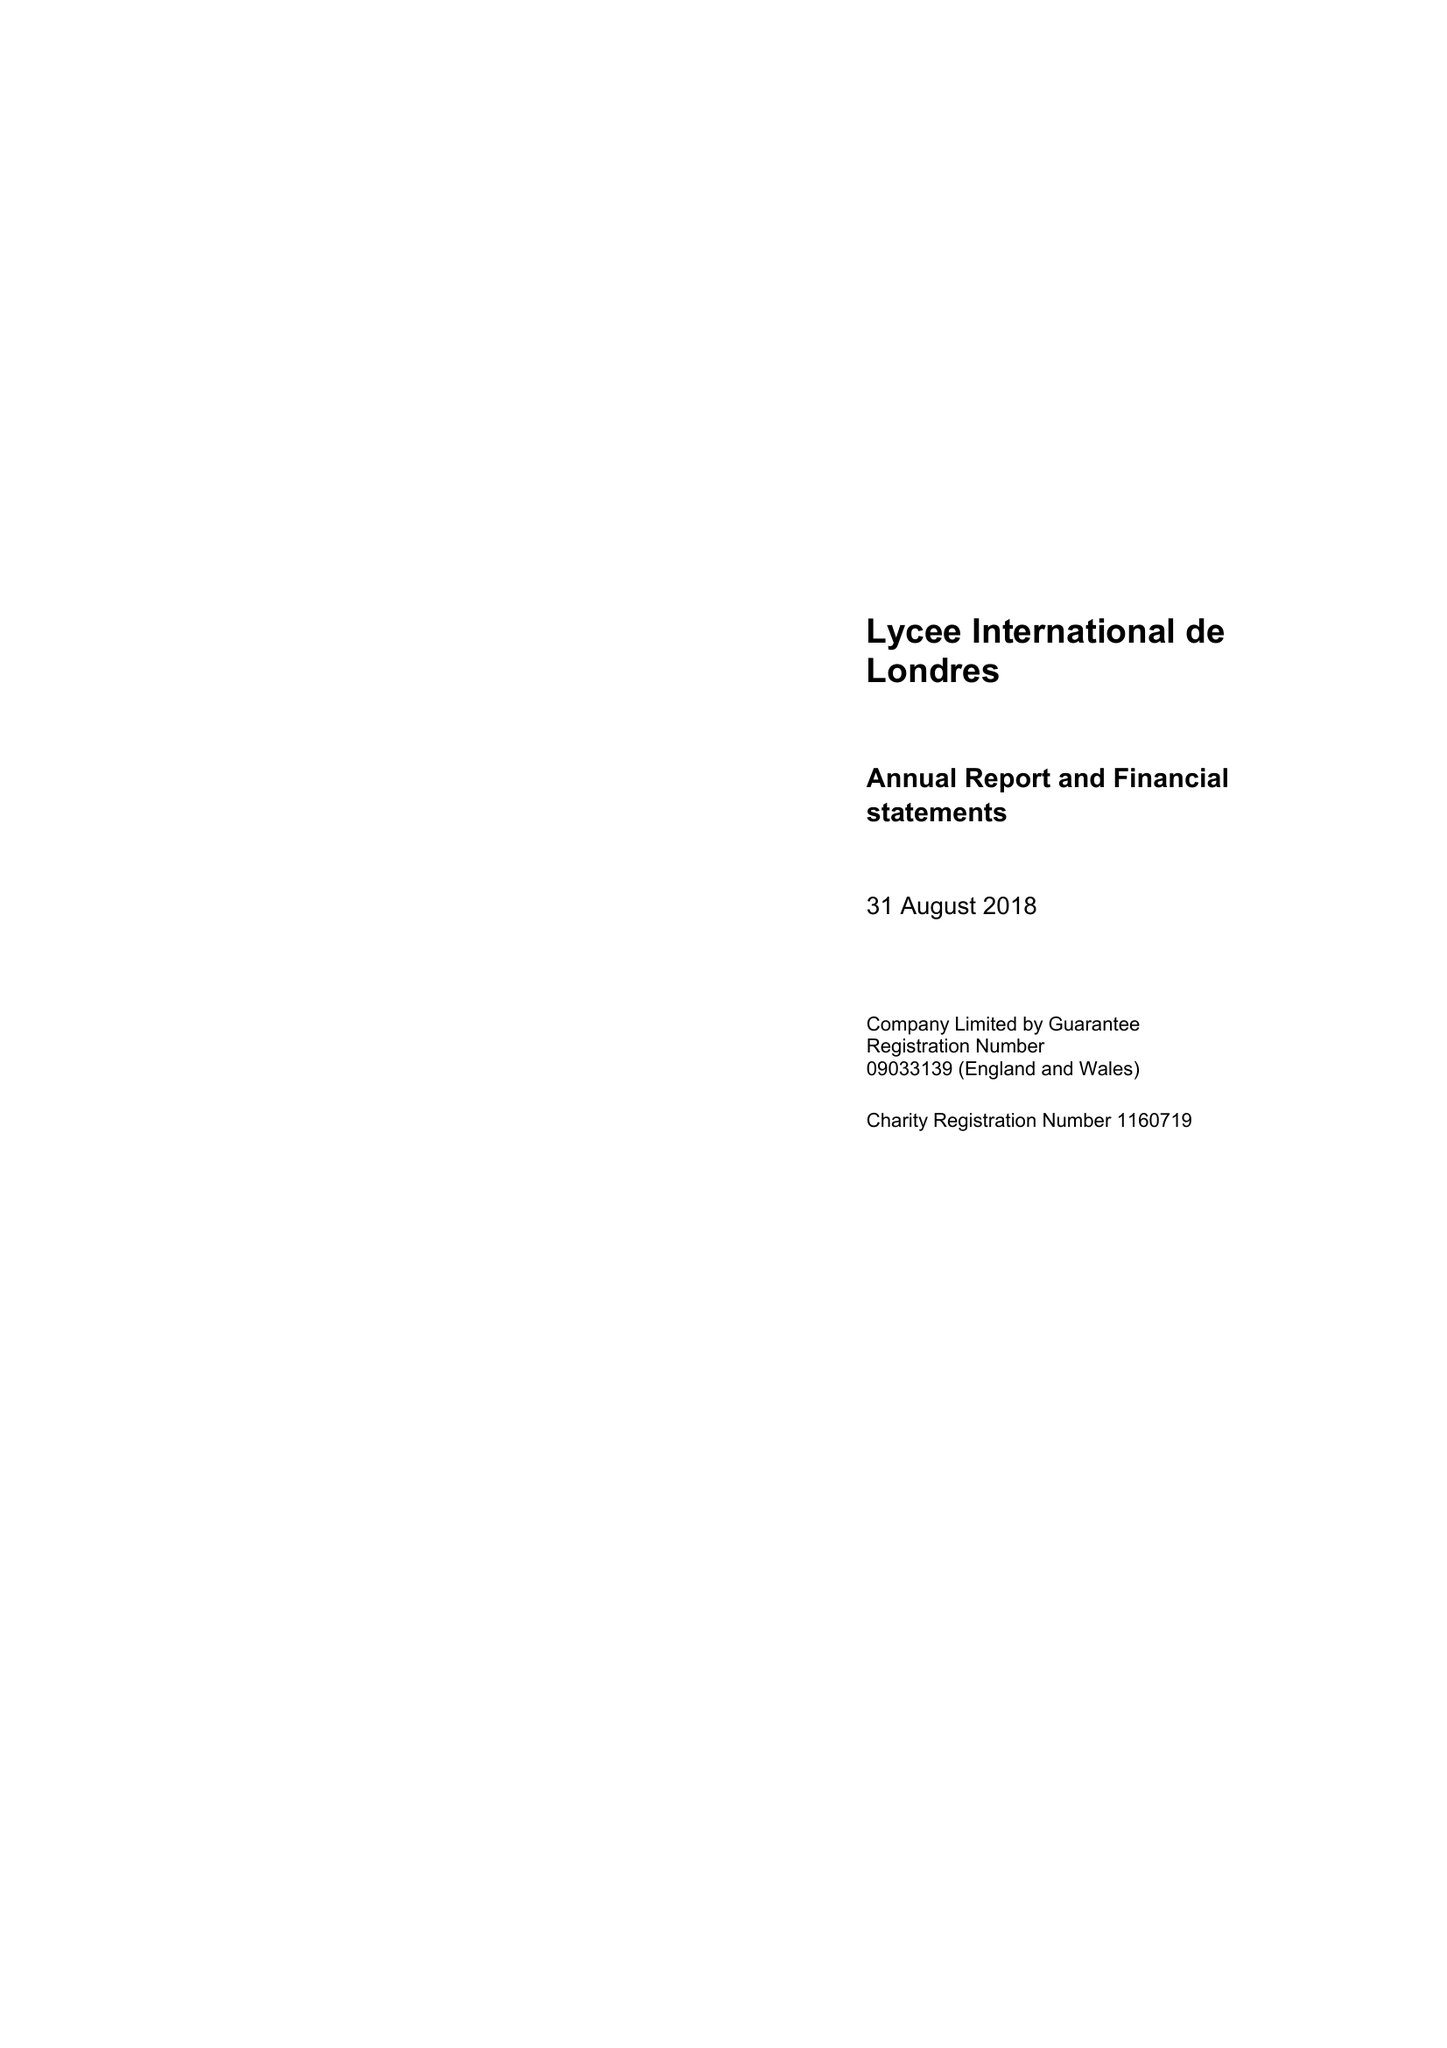What is the value for the spending_annually_in_british_pounds?
Answer the question using a single word or phrase. 11034000.00 